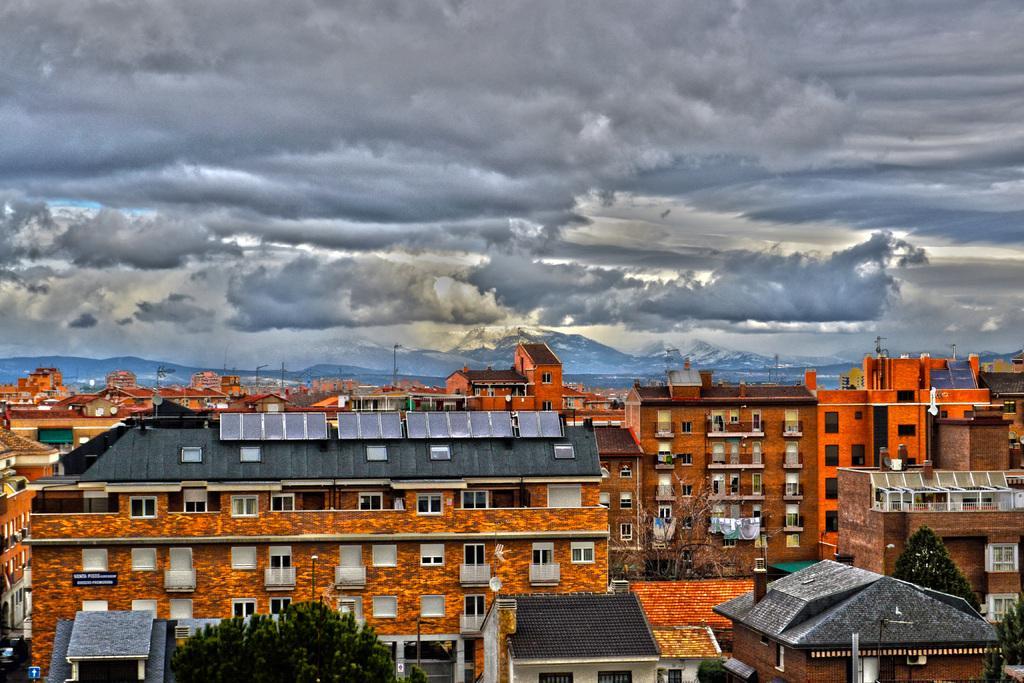Please provide a concise description of this image. In this image we can see many buildings with windows. There are trees. In the background there is sky with clouds. Also there are mountains. 